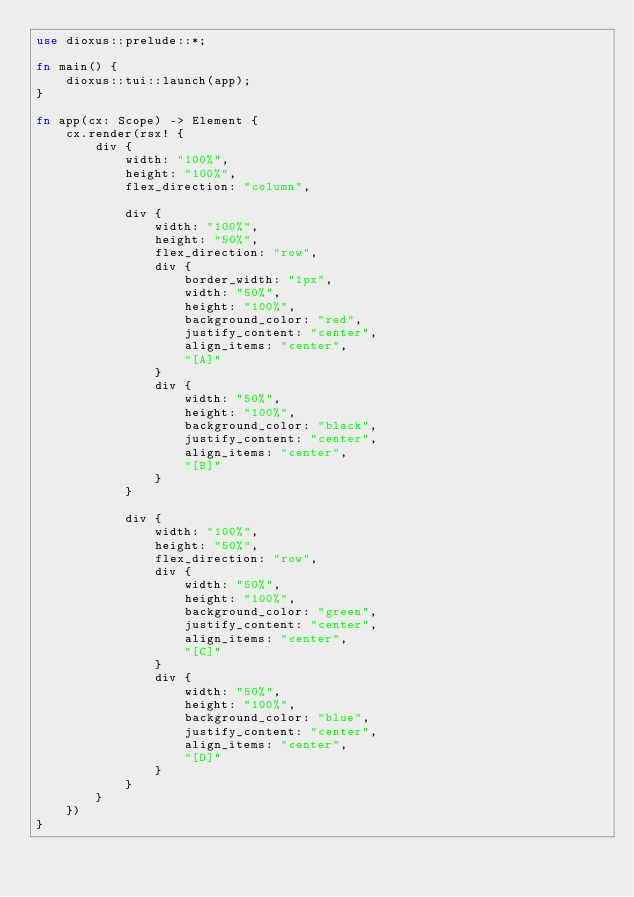Convert code to text. <code><loc_0><loc_0><loc_500><loc_500><_Rust_>use dioxus::prelude::*;

fn main() {
    dioxus::tui::launch(app);
}

fn app(cx: Scope) -> Element {
    cx.render(rsx! {
        div {
            width: "100%",
            height: "100%",
            flex_direction: "column",

            div {
                width: "100%",
                height: "50%",
                flex_direction: "row",
                div {
                    border_width: "1px",
                    width: "50%",
                    height: "100%",
                    background_color: "red",
                    justify_content: "center",
                    align_items: "center",
                    "[A]"
                }
                div {
                    width: "50%",
                    height: "100%",
                    background_color: "black",
                    justify_content: "center",
                    align_items: "center",
                    "[B]"
                }
            }

            div {
                width: "100%",
                height: "50%",
                flex_direction: "row",
                div {
                    width: "50%",
                    height: "100%",
                    background_color: "green",
                    justify_content: "center",
                    align_items: "center",
                    "[C]"
                }
                div {
                    width: "50%",
                    height: "100%",
                    background_color: "blue",
                    justify_content: "center",
                    align_items: "center",
                    "[D]"
                }
            }
        }
    })
}
</code> 